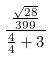Convert formula to latex. <formula><loc_0><loc_0><loc_500><loc_500>\frac { \frac { \sqrt { 2 8 } } { 3 9 9 } } { \frac { 4 } { 4 } + 3 }</formula> 